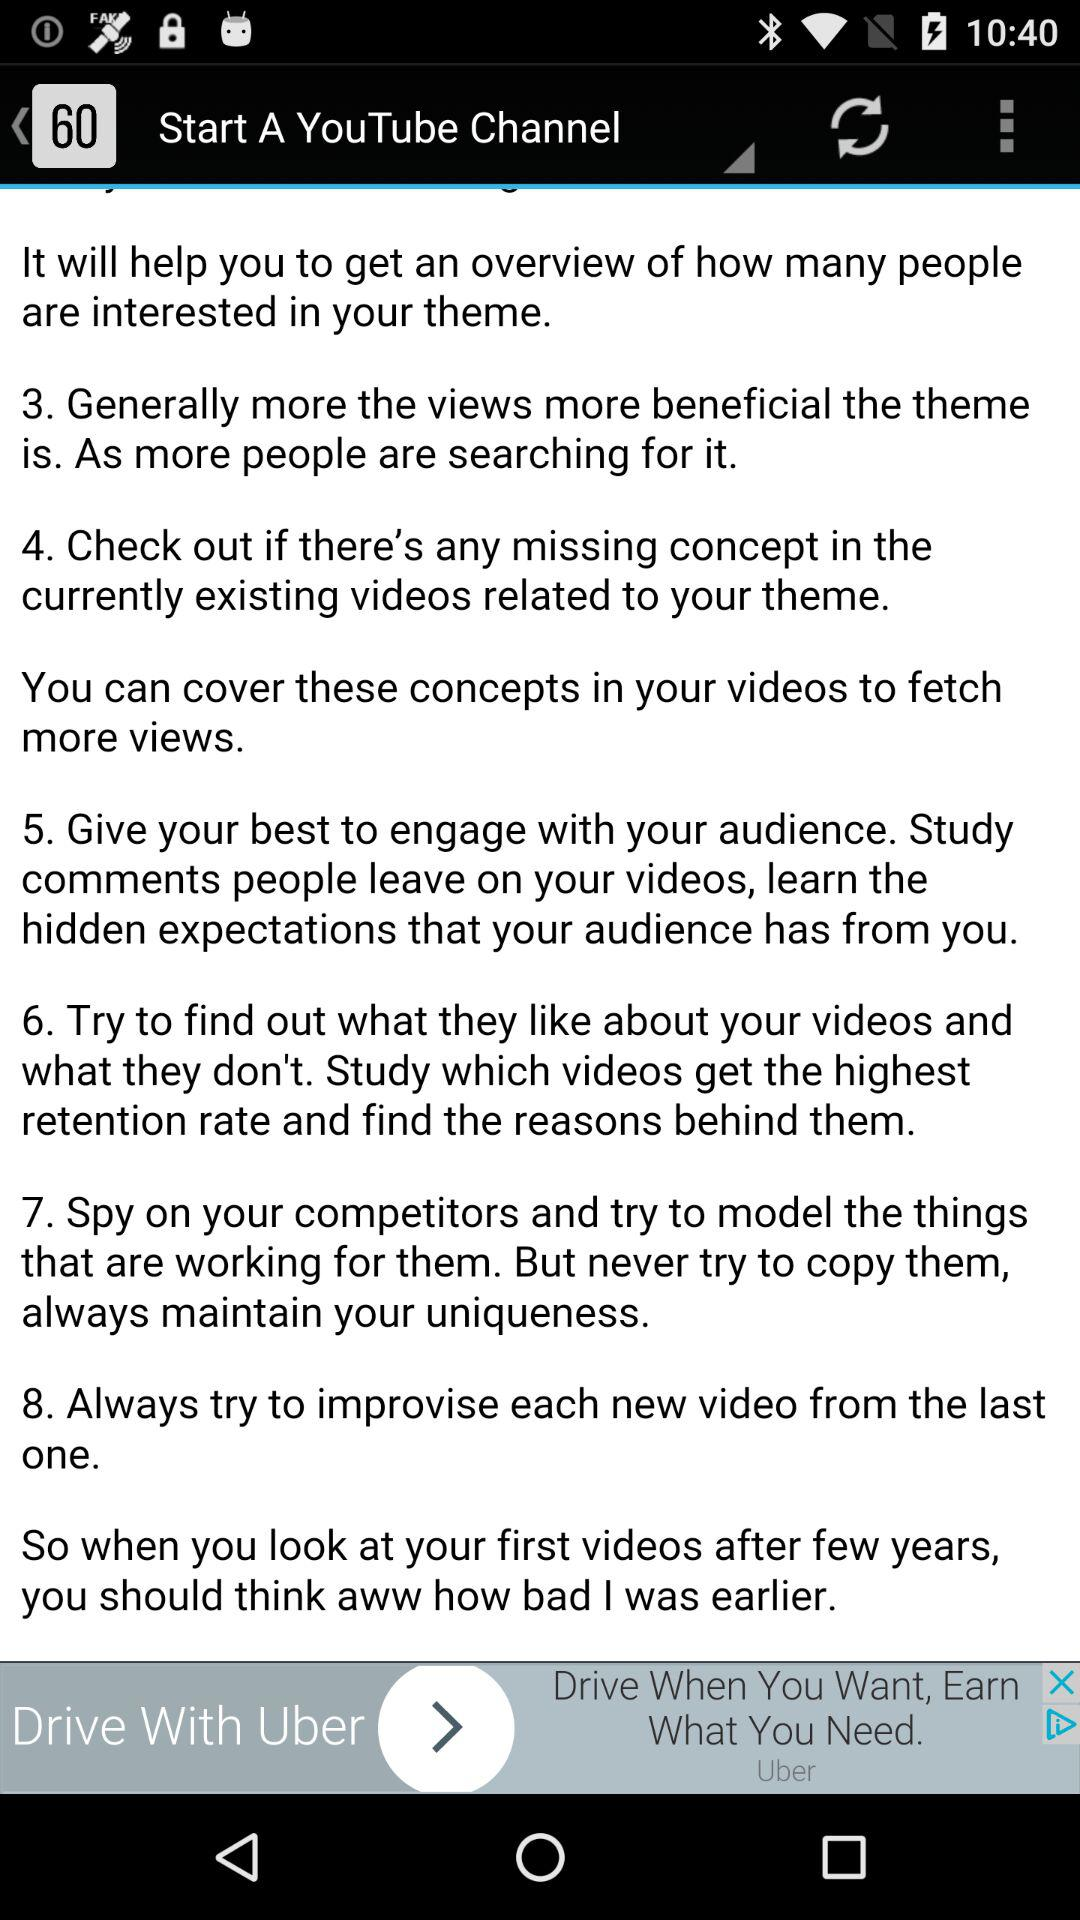How many steps are there in the tutorial to grow your YouTube channel?
Answer the question using a single word or phrase. 8 